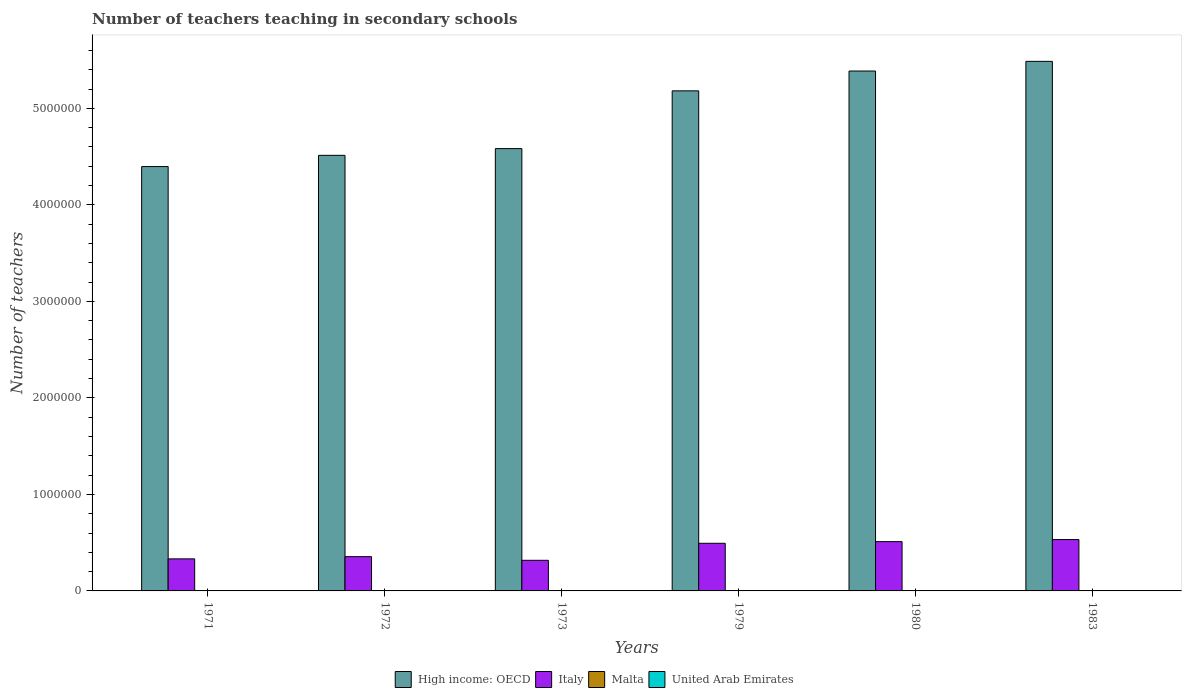Are the number of bars on each tick of the X-axis equal?
Your answer should be compact. Yes. How many bars are there on the 5th tick from the left?
Give a very brief answer. 4. In how many cases, is the number of bars for a given year not equal to the number of legend labels?
Provide a short and direct response. 0. What is the number of teachers teaching in secondary schools in Italy in 1980?
Make the answer very short. 5.11e+05. Across all years, what is the maximum number of teachers teaching in secondary schools in Malta?
Your response must be concise. 2381. Across all years, what is the minimum number of teachers teaching in secondary schools in Malta?
Keep it short and to the point. 1662. In which year was the number of teachers teaching in secondary schools in Italy maximum?
Ensure brevity in your answer.  1983. In which year was the number of teachers teaching in secondary schools in United Arab Emirates minimum?
Your response must be concise. 1971. What is the total number of teachers teaching in secondary schools in Malta in the graph?
Keep it short and to the point. 1.30e+04. What is the difference between the number of teachers teaching in secondary schools in High income: OECD in 1972 and that in 1983?
Give a very brief answer. -9.74e+05. What is the difference between the number of teachers teaching in secondary schools in United Arab Emirates in 1983 and the number of teachers teaching in secondary schools in Italy in 1980?
Keep it short and to the point. -5.07e+05. What is the average number of teachers teaching in secondary schools in Malta per year?
Provide a short and direct response. 2165. In the year 1972, what is the difference between the number of teachers teaching in secondary schools in High income: OECD and number of teachers teaching in secondary schools in Italy?
Offer a terse response. 4.16e+06. In how many years, is the number of teachers teaching in secondary schools in Malta greater than 1400000?
Your answer should be compact. 0. What is the ratio of the number of teachers teaching in secondary schools in Malta in 1980 to that in 1983?
Your answer should be compact. 0.99. Is the number of teachers teaching in secondary schools in High income: OECD in 1971 less than that in 1973?
Provide a succinct answer. Yes. What is the difference between the highest and the second highest number of teachers teaching in secondary schools in High income: OECD?
Your answer should be compact. 1.00e+05. What is the difference between the highest and the lowest number of teachers teaching in secondary schools in Italy?
Ensure brevity in your answer.  2.15e+05. In how many years, is the number of teachers teaching in secondary schools in Italy greater than the average number of teachers teaching in secondary schools in Italy taken over all years?
Offer a very short reply. 3. Is it the case that in every year, the sum of the number of teachers teaching in secondary schools in High income: OECD and number of teachers teaching in secondary schools in United Arab Emirates is greater than the sum of number of teachers teaching in secondary schools in Malta and number of teachers teaching in secondary schools in Italy?
Provide a short and direct response. Yes. What does the 2nd bar from the left in 1973 represents?
Your answer should be very brief. Italy. What does the 3rd bar from the right in 1973 represents?
Make the answer very short. Italy. Is it the case that in every year, the sum of the number of teachers teaching in secondary schools in United Arab Emirates and number of teachers teaching in secondary schools in Malta is greater than the number of teachers teaching in secondary schools in High income: OECD?
Make the answer very short. No. How many bars are there?
Ensure brevity in your answer.  24. How many years are there in the graph?
Your response must be concise. 6. What is the difference between two consecutive major ticks on the Y-axis?
Make the answer very short. 1.00e+06. Are the values on the major ticks of Y-axis written in scientific E-notation?
Give a very brief answer. No. What is the title of the graph?
Keep it short and to the point. Number of teachers teaching in secondary schools. Does "South Africa" appear as one of the legend labels in the graph?
Ensure brevity in your answer.  No. What is the label or title of the X-axis?
Make the answer very short. Years. What is the label or title of the Y-axis?
Your answer should be very brief. Number of teachers. What is the Number of teachers in High income: OECD in 1971?
Your response must be concise. 4.40e+06. What is the Number of teachers in Italy in 1971?
Make the answer very short. 3.32e+05. What is the Number of teachers in Malta in 1971?
Your response must be concise. 1662. What is the Number of teachers in United Arab Emirates in 1971?
Make the answer very short. 363. What is the Number of teachers in High income: OECD in 1972?
Give a very brief answer. 4.51e+06. What is the Number of teachers of Italy in 1972?
Your answer should be very brief. 3.55e+05. What is the Number of teachers in Malta in 1972?
Give a very brief answer. 2381. What is the Number of teachers in United Arab Emirates in 1972?
Keep it short and to the point. 471. What is the Number of teachers in High income: OECD in 1973?
Ensure brevity in your answer.  4.58e+06. What is the Number of teachers in Italy in 1973?
Provide a succinct answer. 3.17e+05. What is the Number of teachers in Malta in 1973?
Ensure brevity in your answer.  2174. What is the Number of teachers of United Arab Emirates in 1973?
Make the answer very short. 713. What is the Number of teachers in High income: OECD in 1979?
Your answer should be very brief. 5.18e+06. What is the Number of teachers of Italy in 1979?
Provide a succinct answer. 4.94e+05. What is the Number of teachers of Malta in 1979?
Give a very brief answer. 2291. What is the Number of teachers in United Arab Emirates in 1979?
Make the answer very short. 2161. What is the Number of teachers of High income: OECD in 1980?
Keep it short and to the point. 5.39e+06. What is the Number of teachers in Italy in 1980?
Make the answer very short. 5.11e+05. What is the Number of teachers of Malta in 1980?
Offer a very short reply. 2229. What is the Number of teachers of United Arab Emirates in 1980?
Provide a short and direct response. 2582. What is the Number of teachers of High income: OECD in 1983?
Your response must be concise. 5.49e+06. What is the Number of teachers of Italy in 1983?
Keep it short and to the point. 5.32e+05. What is the Number of teachers of Malta in 1983?
Keep it short and to the point. 2253. What is the Number of teachers of United Arab Emirates in 1983?
Ensure brevity in your answer.  3588. Across all years, what is the maximum Number of teachers in High income: OECD?
Provide a short and direct response. 5.49e+06. Across all years, what is the maximum Number of teachers in Italy?
Keep it short and to the point. 5.32e+05. Across all years, what is the maximum Number of teachers in Malta?
Give a very brief answer. 2381. Across all years, what is the maximum Number of teachers in United Arab Emirates?
Provide a succinct answer. 3588. Across all years, what is the minimum Number of teachers of High income: OECD?
Provide a short and direct response. 4.40e+06. Across all years, what is the minimum Number of teachers of Italy?
Provide a succinct answer. 3.17e+05. Across all years, what is the minimum Number of teachers of Malta?
Offer a terse response. 1662. Across all years, what is the minimum Number of teachers in United Arab Emirates?
Provide a succinct answer. 363. What is the total Number of teachers of High income: OECD in the graph?
Ensure brevity in your answer.  2.95e+07. What is the total Number of teachers in Italy in the graph?
Your response must be concise. 2.54e+06. What is the total Number of teachers in Malta in the graph?
Your answer should be compact. 1.30e+04. What is the total Number of teachers of United Arab Emirates in the graph?
Provide a short and direct response. 9878. What is the difference between the Number of teachers in High income: OECD in 1971 and that in 1972?
Your response must be concise. -1.16e+05. What is the difference between the Number of teachers in Italy in 1971 and that in 1972?
Your response must be concise. -2.29e+04. What is the difference between the Number of teachers in Malta in 1971 and that in 1972?
Offer a very short reply. -719. What is the difference between the Number of teachers in United Arab Emirates in 1971 and that in 1972?
Make the answer very short. -108. What is the difference between the Number of teachers in High income: OECD in 1971 and that in 1973?
Provide a short and direct response. -1.86e+05. What is the difference between the Number of teachers of Italy in 1971 and that in 1973?
Offer a terse response. 1.49e+04. What is the difference between the Number of teachers of Malta in 1971 and that in 1973?
Give a very brief answer. -512. What is the difference between the Number of teachers in United Arab Emirates in 1971 and that in 1973?
Offer a very short reply. -350. What is the difference between the Number of teachers in High income: OECD in 1971 and that in 1979?
Your answer should be compact. -7.84e+05. What is the difference between the Number of teachers in Italy in 1971 and that in 1979?
Make the answer very short. -1.61e+05. What is the difference between the Number of teachers of Malta in 1971 and that in 1979?
Your answer should be compact. -629. What is the difference between the Number of teachers in United Arab Emirates in 1971 and that in 1979?
Offer a terse response. -1798. What is the difference between the Number of teachers of High income: OECD in 1971 and that in 1980?
Your answer should be compact. -9.90e+05. What is the difference between the Number of teachers of Italy in 1971 and that in 1980?
Your response must be concise. -1.79e+05. What is the difference between the Number of teachers in Malta in 1971 and that in 1980?
Your answer should be very brief. -567. What is the difference between the Number of teachers in United Arab Emirates in 1971 and that in 1980?
Your answer should be compact. -2219. What is the difference between the Number of teachers in High income: OECD in 1971 and that in 1983?
Keep it short and to the point. -1.09e+06. What is the difference between the Number of teachers of Italy in 1971 and that in 1983?
Make the answer very short. -2.00e+05. What is the difference between the Number of teachers in Malta in 1971 and that in 1983?
Your answer should be compact. -591. What is the difference between the Number of teachers of United Arab Emirates in 1971 and that in 1983?
Your answer should be compact. -3225. What is the difference between the Number of teachers in High income: OECD in 1972 and that in 1973?
Your answer should be compact. -6.96e+04. What is the difference between the Number of teachers of Italy in 1972 and that in 1973?
Keep it short and to the point. 3.78e+04. What is the difference between the Number of teachers in Malta in 1972 and that in 1973?
Keep it short and to the point. 207. What is the difference between the Number of teachers in United Arab Emirates in 1972 and that in 1973?
Ensure brevity in your answer.  -242. What is the difference between the Number of teachers in High income: OECD in 1972 and that in 1979?
Ensure brevity in your answer.  -6.68e+05. What is the difference between the Number of teachers of Italy in 1972 and that in 1979?
Ensure brevity in your answer.  -1.39e+05. What is the difference between the Number of teachers in United Arab Emirates in 1972 and that in 1979?
Your response must be concise. -1690. What is the difference between the Number of teachers of High income: OECD in 1972 and that in 1980?
Make the answer very short. -8.74e+05. What is the difference between the Number of teachers in Italy in 1972 and that in 1980?
Ensure brevity in your answer.  -1.56e+05. What is the difference between the Number of teachers of Malta in 1972 and that in 1980?
Provide a succinct answer. 152. What is the difference between the Number of teachers of United Arab Emirates in 1972 and that in 1980?
Give a very brief answer. -2111. What is the difference between the Number of teachers of High income: OECD in 1972 and that in 1983?
Your answer should be very brief. -9.74e+05. What is the difference between the Number of teachers of Italy in 1972 and that in 1983?
Provide a succinct answer. -1.77e+05. What is the difference between the Number of teachers in Malta in 1972 and that in 1983?
Offer a very short reply. 128. What is the difference between the Number of teachers of United Arab Emirates in 1972 and that in 1983?
Your answer should be very brief. -3117. What is the difference between the Number of teachers of High income: OECD in 1973 and that in 1979?
Give a very brief answer. -5.98e+05. What is the difference between the Number of teachers in Italy in 1973 and that in 1979?
Your answer should be compact. -1.76e+05. What is the difference between the Number of teachers in Malta in 1973 and that in 1979?
Keep it short and to the point. -117. What is the difference between the Number of teachers in United Arab Emirates in 1973 and that in 1979?
Provide a short and direct response. -1448. What is the difference between the Number of teachers in High income: OECD in 1973 and that in 1980?
Ensure brevity in your answer.  -8.04e+05. What is the difference between the Number of teachers of Italy in 1973 and that in 1980?
Your answer should be very brief. -1.94e+05. What is the difference between the Number of teachers in Malta in 1973 and that in 1980?
Make the answer very short. -55. What is the difference between the Number of teachers of United Arab Emirates in 1973 and that in 1980?
Provide a succinct answer. -1869. What is the difference between the Number of teachers of High income: OECD in 1973 and that in 1983?
Your response must be concise. -9.04e+05. What is the difference between the Number of teachers in Italy in 1973 and that in 1983?
Your answer should be compact. -2.15e+05. What is the difference between the Number of teachers in Malta in 1973 and that in 1983?
Keep it short and to the point. -79. What is the difference between the Number of teachers in United Arab Emirates in 1973 and that in 1983?
Your response must be concise. -2875. What is the difference between the Number of teachers of High income: OECD in 1979 and that in 1980?
Keep it short and to the point. -2.05e+05. What is the difference between the Number of teachers of Italy in 1979 and that in 1980?
Give a very brief answer. -1.72e+04. What is the difference between the Number of teachers in Malta in 1979 and that in 1980?
Provide a short and direct response. 62. What is the difference between the Number of teachers of United Arab Emirates in 1979 and that in 1980?
Your response must be concise. -421. What is the difference between the Number of teachers in High income: OECD in 1979 and that in 1983?
Your answer should be very brief. -3.06e+05. What is the difference between the Number of teachers in Italy in 1979 and that in 1983?
Provide a short and direct response. -3.88e+04. What is the difference between the Number of teachers in United Arab Emirates in 1979 and that in 1983?
Give a very brief answer. -1427. What is the difference between the Number of teachers of High income: OECD in 1980 and that in 1983?
Give a very brief answer. -1.00e+05. What is the difference between the Number of teachers of Italy in 1980 and that in 1983?
Ensure brevity in your answer.  -2.15e+04. What is the difference between the Number of teachers in Malta in 1980 and that in 1983?
Ensure brevity in your answer.  -24. What is the difference between the Number of teachers in United Arab Emirates in 1980 and that in 1983?
Give a very brief answer. -1006. What is the difference between the Number of teachers in High income: OECD in 1971 and the Number of teachers in Italy in 1972?
Keep it short and to the point. 4.04e+06. What is the difference between the Number of teachers of High income: OECD in 1971 and the Number of teachers of Malta in 1972?
Make the answer very short. 4.39e+06. What is the difference between the Number of teachers in High income: OECD in 1971 and the Number of teachers in United Arab Emirates in 1972?
Provide a succinct answer. 4.40e+06. What is the difference between the Number of teachers in Italy in 1971 and the Number of teachers in Malta in 1972?
Your answer should be compact. 3.30e+05. What is the difference between the Number of teachers in Italy in 1971 and the Number of teachers in United Arab Emirates in 1972?
Provide a succinct answer. 3.32e+05. What is the difference between the Number of teachers in Malta in 1971 and the Number of teachers in United Arab Emirates in 1972?
Keep it short and to the point. 1191. What is the difference between the Number of teachers in High income: OECD in 1971 and the Number of teachers in Italy in 1973?
Provide a short and direct response. 4.08e+06. What is the difference between the Number of teachers in High income: OECD in 1971 and the Number of teachers in Malta in 1973?
Provide a succinct answer. 4.39e+06. What is the difference between the Number of teachers in High income: OECD in 1971 and the Number of teachers in United Arab Emirates in 1973?
Your response must be concise. 4.40e+06. What is the difference between the Number of teachers in Italy in 1971 and the Number of teachers in Malta in 1973?
Provide a succinct answer. 3.30e+05. What is the difference between the Number of teachers of Italy in 1971 and the Number of teachers of United Arab Emirates in 1973?
Offer a very short reply. 3.31e+05. What is the difference between the Number of teachers in Malta in 1971 and the Number of teachers in United Arab Emirates in 1973?
Provide a succinct answer. 949. What is the difference between the Number of teachers of High income: OECD in 1971 and the Number of teachers of Italy in 1979?
Keep it short and to the point. 3.90e+06. What is the difference between the Number of teachers in High income: OECD in 1971 and the Number of teachers in Malta in 1979?
Provide a succinct answer. 4.39e+06. What is the difference between the Number of teachers of High income: OECD in 1971 and the Number of teachers of United Arab Emirates in 1979?
Your answer should be very brief. 4.39e+06. What is the difference between the Number of teachers in Italy in 1971 and the Number of teachers in Malta in 1979?
Give a very brief answer. 3.30e+05. What is the difference between the Number of teachers in Italy in 1971 and the Number of teachers in United Arab Emirates in 1979?
Give a very brief answer. 3.30e+05. What is the difference between the Number of teachers in Malta in 1971 and the Number of teachers in United Arab Emirates in 1979?
Give a very brief answer. -499. What is the difference between the Number of teachers of High income: OECD in 1971 and the Number of teachers of Italy in 1980?
Provide a short and direct response. 3.89e+06. What is the difference between the Number of teachers of High income: OECD in 1971 and the Number of teachers of Malta in 1980?
Offer a very short reply. 4.39e+06. What is the difference between the Number of teachers of High income: OECD in 1971 and the Number of teachers of United Arab Emirates in 1980?
Offer a very short reply. 4.39e+06. What is the difference between the Number of teachers of Italy in 1971 and the Number of teachers of Malta in 1980?
Offer a very short reply. 3.30e+05. What is the difference between the Number of teachers in Italy in 1971 and the Number of teachers in United Arab Emirates in 1980?
Offer a very short reply. 3.30e+05. What is the difference between the Number of teachers of Malta in 1971 and the Number of teachers of United Arab Emirates in 1980?
Offer a terse response. -920. What is the difference between the Number of teachers of High income: OECD in 1971 and the Number of teachers of Italy in 1983?
Offer a very short reply. 3.86e+06. What is the difference between the Number of teachers in High income: OECD in 1971 and the Number of teachers in Malta in 1983?
Your response must be concise. 4.39e+06. What is the difference between the Number of teachers in High income: OECD in 1971 and the Number of teachers in United Arab Emirates in 1983?
Provide a short and direct response. 4.39e+06. What is the difference between the Number of teachers in Italy in 1971 and the Number of teachers in Malta in 1983?
Make the answer very short. 3.30e+05. What is the difference between the Number of teachers of Italy in 1971 and the Number of teachers of United Arab Emirates in 1983?
Offer a very short reply. 3.29e+05. What is the difference between the Number of teachers in Malta in 1971 and the Number of teachers in United Arab Emirates in 1983?
Provide a short and direct response. -1926. What is the difference between the Number of teachers in High income: OECD in 1972 and the Number of teachers in Italy in 1973?
Provide a short and direct response. 4.20e+06. What is the difference between the Number of teachers in High income: OECD in 1972 and the Number of teachers in Malta in 1973?
Offer a terse response. 4.51e+06. What is the difference between the Number of teachers in High income: OECD in 1972 and the Number of teachers in United Arab Emirates in 1973?
Offer a terse response. 4.51e+06. What is the difference between the Number of teachers in Italy in 1972 and the Number of teachers in Malta in 1973?
Provide a short and direct response. 3.53e+05. What is the difference between the Number of teachers in Italy in 1972 and the Number of teachers in United Arab Emirates in 1973?
Make the answer very short. 3.54e+05. What is the difference between the Number of teachers of Malta in 1972 and the Number of teachers of United Arab Emirates in 1973?
Offer a very short reply. 1668. What is the difference between the Number of teachers in High income: OECD in 1972 and the Number of teachers in Italy in 1979?
Your response must be concise. 4.02e+06. What is the difference between the Number of teachers of High income: OECD in 1972 and the Number of teachers of Malta in 1979?
Provide a succinct answer. 4.51e+06. What is the difference between the Number of teachers of High income: OECD in 1972 and the Number of teachers of United Arab Emirates in 1979?
Offer a very short reply. 4.51e+06. What is the difference between the Number of teachers of Italy in 1972 and the Number of teachers of Malta in 1979?
Make the answer very short. 3.53e+05. What is the difference between the Number of teachers of Italy in 1972 and the Number of teachers of United Arab Emirates in 1979?
Make the answer very short. 3.53e+05. What is the difference between the Number of teachers in Malta in 1972 and the Number of teachers in United Arab Emirates in 1979?
Keep it short and to the point. 220. What is the difference between the Number of teachers of High income: OECD in 1972 and the Number of teachers of Italy in 1980?
Give a very brief answer. 4.00e+06. What is the difference between the Number of teachers of High income: OECD in 1972 and the Number of teachers of Malta in 1980?
Make the answer very short. 4.51e+06. What is the difference between the Number of teachers in High income: OECD in 1972 and the Number of teachers in United Arab Emirates in 1980?
Provide a short and direct response. 4.51e+06. What is the difference between the Number of teachers of Italy in 1972 and the Number of teachers of Malta in 1980?
Your answer should be very brief. 3.53e+05. What is the difference between the Number of teachers in Italy in 1972 and the Number of teachers in United Arab Emirates in 1980?
Give a very brief answer. 3.52e+05. What is the difference between the Number of teachers in Malta in 1972 and the Number of teachers in United Arab Emirates in 1980?
Offer a terse response. -201. What is the difference between the Number of teachers of High income: OECD in 1972 and the Number of teachers of Italy in 1983?
Provide a short and direct response. 3.98e+06. What is the difference between the Number of teachers of High income: OECD in 1972 and the Number of teachers of Malta in 1983?
Keep it short and to the point. 4.51e+06. What is the difference between the Number of teachers of High income: OECD in 1972 and the Number of teachers of United Arab Emirates in 1983?
Keep it short and to the point. 4.51e+06. What is the difference between the Number of teachers in Italy in 1972 and the Number of teachers in Malta in 1983?
Offer a terse response. 3.53e+05. What is the difference between the Number of teachers in Italy in 1972 and the Number of teachers in United Arab Emirates in 1983?
Give a very brief answer. 3.51e+05. What is the difference between the Number of teachers of Malta in 1972 and the Number of teachers of United Arab Emirates in 1983?
Make the answer very short. -1207. What is the difference between the Number of teachers of High income: OECD in 1973 and the Number of teachers of Italy in 1979?
Offer a terse response. 4.09e+06. What is the difference between the Number of teachers in High income: OECD in 1973 and the Number of teachers in Malta in 1979?
Ensure brevity in your answer.  4.58e+06. What is the difference between the Number of teachers of High income: OECD in 1973 and the Number of teachers of United Arab Emirates in 1979?
Your answer should be very brief. 4.58e+06. What is the difference between the Number of teachers of Italy in 1973 and the Number of teachers of Malta in 1979?
Offer a very short reply. 3.15e+05. What is the difference between the Number of teachers of Italy in 1973 and the Number of teachers of United Arab Emirates in 1979?
Keep it short and to the point. 3.15e+05. What is the difference between the Number of teachers of High income: OECD in 1973 and the Number of teachers of Italy in 1980?
Provide a succinct answer. 4.07e+06. What is the difference between the Number of teachers in High income: OECD in 1973 and the Number of teachers in Malta in 1980?
Keep it short and to the point. 4.58e+06. What is the difference between the Number of teachers in High income: OECD in 1973 and the Number of teachers in United Arab Emirates in 1980?
Provide a short and direct response. 4.58e+06. What is the difference between the Number of teachers of Italy in 1973 and the Number of teachers of Malta in 1980?
Make the answer very short. 3.15e+05. What is the difference between the Number of teachers in Italy in 1973 and the Number of teachers in United Arab Emirates in 1980?
Provide a short and direct response. 3.15e+05. What is the difference between the Number of teachers in Malta in 1973 and the Number of teachers in United Arab Emirates in 1980?
Offer a terse response. -408. What is the difference between the Number of teachers in High income: OECD in 1973 and the Number of teachers in Italy in 1983?
Provide a succinct answer. 4.05e+06. What is the difference between the Number of teachers in High income: OECD in 1973 and the Number of teachers in Malta in 1983?
Offer a very short reply. 4.58e+06. What is the difference between the Number of teachers of High income: OECD in 1973 and the Number of teachers of United Arab Emirates in 1983?
Keep it short and to the point. 4.58e+06. What is the difference between the Number of teachers of Italy in 1973 and the Number of teachers of Malta in 1983?
Keep it short and to the point. 3.15e+05. What is the difference between the Number of teachers of Italy in 1973 and the Number of teachers of United Arab Emirates in 1983?
Offer a very short reply. 3.14e+05. What is the difference between the Number of teachers of Malta in 1973 and the Number of teachers of United Arab Emirates in 1983?
Keep it short and to the point. -1414. What is the difference between the Number of teachers in High income: OECD in 1979 and the Number of teachers in Italy in 1980?
Your answer should be compact. 4.67e+06. What is the difference between the Number of teachers in High income: OECD in 1979 and the Number of teachers in Malta in 1980?
Make the answer very short. 5.18e+06. What is the difference between the Number of teachers in High income: OECD in 1979 and the Number of teachers in United Arab Emirates in 1980?
Give a very brief answer. 5.18e+06. What is the difference between the Number of teachers of Italy in 1979 and the Number of teachers of Malta in 1980?
Your answer should be compact. 4.91e+05. What is the difference between the Number of teachers in Italy in 1979 and the Number of teachers in United Arab Emirates in 1980?
Keep it short and to the point. 4.91e+05. What is the difference between the Number of teachers in Malta in 1979 and the Number of teachers in United Arab Emirates in 1980?
Keep it short and to the point. -291. What is the difference between the Number of teachers of High income: OECD in 1979 and the Number of teachers of Italy in 1983?
Keep it short and to the point. 4.65e+06. What is the difference between the Number of teachers in High income: OECD in 1979 and the Number of teachers in Malta in 1983?
Give a very brief answer. 5.18e+06. What is the difference between the Number of teachers in High income: OECD in 1979 and the Number of teachers in United Arab Emirates in 1983?
Give a very brief answer. 5.18e+06. What is the difference between the Number of teachers in Italy in 1979 and the Number of teachers in Malta in 1983?
Keep it short and to the point. 4.91e+05. What is the difference between the Number of teachers in Italy in 1979 and the Number of teachers in United Arab Emirates in 1983?
Your answer should be very brief. 4.90e+05. What is the difference between the Number of teachers of Malta in 1979 and the Number of teachers of United Arab Emirates in 1983?
Keep it short and to the point. -1297. What is the difference between the Number of teachers of High income: OECD in 1980 and the Number of teachers of Italy in 1983?
Your response must be concise. 4.85e+06. What is the difference between the Number of teachers in High income: OECD in 1980 and the Number of teachers in Malta in 1983?
Your response must be concise. 5.38e+06. What is the difference between the Number of teachers of High income: OECD in 1980 and the Number of teachers of United Arab Emirates in 1983?
Provide a succinct answer. 5.38e+06. What is the difference between the Number of teachers of Italy in 1980 and the Number of teachers of Malta in 1983?
Make the answer very short. 5.09e+05. What is the difference between the Number of teachers in Italy in 1980 and the Number of teachers in United Arab Emirates in 1983?
Your response must be concise. 5.07e+05. What is the difference between the Number of teachers in Malta in 1980 and the Number of teachers in United Arab Emirates in 1983?
Offer a terse response. -1359. What is the average Number of teachers in High income: OECD per year?
Keep it short and to the point. 4.92e+06. What is the average Number of teachers of Italy per year?
Ensure brevity in your answer.  4.23e+05. What is the average Number of teachers of Malta per year?
Provide a succinct answer. 2165. What is the average Number of teachers of United Arab Emirates per year?
Your answer should be very brief. 1646.33. In the year 1971, what is the difference between the Number of teachers in High income: OECD and Number of teachers in Italy?
Make the answer very short. 4.06e+06. In the year 1971, what is the difference between the Number of teachers of High income: OECD and Number of teachers of Malta?
Provide a short and direct response. 4.40e+06. In the year 1971, what is the difference between the Number of teachers in High income: OECD and Number of teachers in United Arab Emirates?
Your answer should be compact. 4.40e+06. In the year 1971, what is the difference between the Number of teachers in Italy and Number of teachers in Malta?
Provide a succinct answer. 3.30e+05. In the year 1971, what is the difference between the Number of teachers in Italy and Number of teachers in United Arab Emirates?
Make the answer very short. 3.32e+05. In the year 1971, what is the difference between the Number of teachers in Malta and Number of teachers in United Arab Emirates?
Your answer should be compact. 1299. In the year 1972, what is the difference between the Number of teachers of High income: OECD and Number of teachers of Italy?
Offer a terse response. 4.16e+06. In the year 1972, what is the difference between the Number of teachers in High income: OECD and Number of teachers in Malta?
Your response must be concise. 4.51e+06. In the year 1972, what is the difference between the Number of teachers of High income: OECD and Number of teachers of United Arab Emirates?
Make the answer very short. 4.51e+06. In the year 1972, what is the difference between the Number of teachers in Italy and Number of teachers in Malta?
Offer a terse response. 3.53e+05. In the year 1972, what is the difference between the Number of teachers of Italy and Number of teachers of United Arab Emirates?
Your answer should be very brief. 3.55e+05. In the year 1972, what is the difference between the Number of teachers in Malta and Number of teachers in United Arab Emirates?
Make the answer very short. 1910. In the year 1973, what is the difference between the Number of teachers of High income: OECD and Number of teachers of Italy?
Offer a very short reply. 4.27e+06. In the year 1973, what is the difference between the Number of teachers in High income: OECD and Number of teachers in Malta?
Offer a terse response. 4.58e+06. In the year 1973, what is the difference between the Number of teachers of High income: OECD and Number of teachers of United Arab Emirates?
Provide a short and direct response. 4.58e+06. In the year 1973, what is the difference between the Number of teachers of Italy and Number of teachers of Malta?
Your answer should be compact. 3.15e+05. In the year 1973, what is the difference between the Number of teachers of Italy and Number of teachers of United Arab Emirates?
Your answer should be very brief. 3.16e+05. In the year 1973, what is the difference between the Number of teachers of Malta and Number of teachers of United Arab Emirates?
Give a very brief answer. 1461. In the year 1979, what is the difference between the Number of teachers in High income: OECD and Number of teachers in Italy?
Give a very brief answer. 4.69e+06. In the year 1979, what is the difference between the Number of teachers of High income: OECD and Number of teachers of Malta?
Offer a very short reply. 5.18e+06. In the year 1979, what is the difference between the Number of teachers of High income: OECD and Number of teachers of United Arab Emirates?
Offer a terse response. 5.18e+06. In the year 1979, what is the difference between the Number of teachers of Italy and Number of teachers of Malta?
Make the answer very short. 4.91e+05. In the year 1979, what is the difference between the Number of teachers in Italy and Number of teachers in United Arab Emirates?
Keep it short and to the point. 4.91e+05. In the year 1979, what is the difference between the Number of teachers in Malta and Number of teachers in United Arab Emirates?
Provide a succinct answer. 130. In the year 1980, what is the difference between the Number of teachers in High income: OECD and Number of teachers in Italy?
Make the answer very short. 4.88e+06. In the year 1980, what is the difference between the Number of teachers in High income: OECD and Number of teachers in Malta?
Offer a terse response. 5.38e+06. In the year 1980, what is the difference between the Number of teachers of High income: OECD and Number of teachers of United Arab Emirates?
Provide a short and direct response. 5.38e+06. In the year 1980, what is the difference between the Number of teachers in Italy and Number of teachers in Malta?
Offer a very short reply. 5.09e+05. In the year 1980, what is the difference between the Number of teachers in Italy and Number of teachers in United Arab Emirates?
Your answer should be compact. 5.08e+05. In the year 1980, what is the difference between the Number of teachers of Malta and Number of teachers of United Arab Emirates?
Your response must be concise. -353. In the year 1983, what is the difference between the Number of teachers of High income: OECD and Number of teachers of Italy?
Offer a very short reply. 4.95e+06. In the year 1983, what is the difference between the Number of teachers in High income: OECD and Number of teachers in Malta?
Offer a very short reply. 5.48e+06. In the year 1983, what is the difference between the Number of teachers of High income: OECD and Number of teachers of United Arab Emirates?
Keep it short and to the point. 5.48e+06. In the year 1983, what is the difference between the Number of teachers in Italy and Number of teachers in Malta?
Make the answer very short. 5.30e+05. In the year 1983, what is the difference between the Number of teachers of Italy and Number of teachers of United Arab Emirates?
Keep it short and to the point. 5.29e+05. In the year 1983, what is the difference between the Number of teachers in Malta and Number of teachers in United Arab Emirates?
Your answer should be compact. -1335. What is the ratio of the Number of teachers of High income: OECD in 1971 to that in 1972?
Offer a very short reply. 0.97. What is the ratio of the Number of teachers in Italy in 1971 to that in 1972?
Offer a terse response. 0.94. What is the ratio of the Number of teachers of Malta in 1971 to that in 1972?
Offer a very short reply. 0.7. What is the ratio of the Number of teachers in United Arab Emirates in 1971 to that in 1972?
Provide a short and direct response. 0.77. What is the ratio of the Number of teachers in High income: OECD in 1971 to that in 1973?
Offer a very short reply. 0.96. What is the ratio of the Number of teachers in Italy in 1971 to that in 1973?
Offer a terse response. 1.05. What is the ratio of the Number of teachers of Malta in 1971 to that in 1973?
Give a very brief answer. 0.76. What is the ratio of the Number of teachers in United Arab Emirates in 1971 to that in 1973?
Your answer should be very brief. 0.51. What is the ratio of the Number of teachers in High income: OECD in 1971 to that in 1979?
Provide a short and direct response. 0.85. What is the ratio of the Number of teachers in Italy in 1971 to that in 1979?
Your response must be concise. 0.67. What is the ratio of the Number of teachers of Malta in 1971 to that in 1979?
Provide a succinct answer. 0.73. What is the ratio of the Number of teachers of United Arab Emirates in 1971 to that in 1979?
Your answer should be compact. 0.17. What is the ratio of the Number of teachers of High income: OECD in 1971 to that in 1980?
Make the answer very short. 0.82. What is the ratio of the Number of teachers in Italy in 1971 to that in 1980?
Make the answer very short. 0.65. What is the ratio of the Number of teachers of Malta in 1971 to that in 1980?
Provide a succinct answer. 0.75. What is the ratio of the Number of teachers in United Arab Emirates in 1971 to that in 1980?
Keep it short and to the point. 0.14. What is the ratio of the Number of teachers in High income: OECD in 1971 to that in 1983?
Your answer should be very brief. 0.8. What is the ratio of the Number of teachers in Italy in 1971 to that in 1983?
Keep it short and to the point. 0.62. What is the ratio of the Number of teachers of Malta in 1971 to that in 1983?
Offer a very short reply. 0.74. What is the ratio of the Number of teachers of United Arab Emirates in 1971 to that in 1983?
Your answer should be compact. 0.1. What is the ratio of the Number of teachers of Italy in 1972 to that in 1973?
Your answer should be very brief. 1.12. What is the ratio of the Number of teachers of Malta in 1972 to that in 1973?
Your answer should be compact. 1.1. What is the ratio of the Number of teachers in United Arab Emirates in 1972 to that in 1973?
Give a very brief answer. 0.66. What is the ratio of the Number of teachers of High income: OECD in 1972 to that in 1979?
Your answer should be very brief. 0.87. What is the ratio of the Number of teachers of Italy in 1972 to that in 1979?
Your answer should be compact. 0.72. What is the ratio of the Number of teachers of Malta in 1972 to that in 1979?
Give a very brief answer. 1.04. What is the ratio of the Number of teachers of United Arab Emirates in 1972 to that in 1979?
Provide a short and direct response. 0.22. What is the ratio of the Number of teachers of High income: OECD in 1972 to that in 1980?
Your answer should be very brief. 0.84. What is the ratio of the Number of teachers of Italy in 1972 to that in 1980?
Your answer should be compact. 0.69. What is the ratio of the Number of teachers of Malta in 1972 to that in 1980?
Give a very brief answer. 1.07. What is the ratio of the Number of teachers in United Arab Emirates in 1972 to that in 1980?
Your answer should be very brief. 0.18. What is the ratio of the Number of teachers of High income: OECD in 1972 to that in 1983?
Your response must be concise. 0.82. What is the ratio of the Number of teachers of Italy in 1972 to that in 1983?
Make the answer very short. 0.67. What is the ratio of the Number of teachers of Malta in 1972 to that in 1983?
Your answer should be very brief. 1.06. What is the ratio of the Number of teachers of United Arab Emirates in 1972 to that in 1983?
Provide a succinct answer. 0.13. What is the ratio of the Number of teachers of High income: OECD in 1973 to that in 1979?
Provide a short and direct response. 0.88. What is the ratio of the Number of teachers of Italy in 1973 to that in 1979?
Ensure brevity in your answer.  0.64. What is the ratio of the Number of teachers of Malta in 1973 to that in 1979?
Provide a succinct answer. 0.95. What is the ratio of the Number of teachers of United Arab Emirates in 1973 to that in 1979?
Ensure brevity in your answer.  0.33. What is the ratio of the Number of teachers of High income: OECD in 1973 to that in 1980?
Your response must be concise. 0.85. What is the ratio of the Number of teachers of Italy in 1973 to that in 1980?
Provide a succinct answer. 0.62. What is the ratio of the Number of teachers of Malta in 1973 to that in 1980?
Provide a short and direct response. 0.98. What is the ratio of the Number of teachers in United Arab Emirates in 1973 to that in 1980?
Make the answer very short. 0.28. What is the ratio of the Number of teachers of High income: OECD in 1973 to that in 1983?
Your response must be concise. 0.84. What is the ratio of the Number of teachers of Italy in 1973 to that in 1983?
Provide a succinct answer. 0.6. What is the ratio of the Number of teachers of Malta in 1973 to that in 1983?
Make the answer very short. 0.96. What is the ratio of the Number of teachers in United Arab Emirates in 1973 to that in 1983?
Your answer should be very brief. 0.2. What is the ratio of the Number of teachers of High income: OECD in 1979 to that in 1980?
Your answer should be compact. 0.96. What is the ratio of the Number of teachers in Italy in 1979 to that in 1980?
Ensure brevity in your answer.  0.97. What is the ratio of the Number of teachers in Malta in 1979 to that in 1980?
Offer a terse response. 1.03. What is the ratio of the Number of teachers in United Arab Emirates in 1979 to that in 1980?
Keep it short and to the point. 0.84. What is the ratio of the Number of teachers of High income: OECD in 1979 to that in 1983?
Your response must be concise. 0.94. What is the ratio of the Number of teachers of Italy in 1979 to that in 1983?
Your answer should be compact. 0.93. What is the ratio of the Number of teachers of Malta in 1979 to that in 1983?
Your answer should be very brief. 1.02. What is the ratio of the Number of teachers in United Arab Emirates in 1979 to that in 1983?
Make the answer very short. 0.6. What is the ratio of the Number of teachers in High income: OECD in 1980 to that in 1983?
Your answer should be very brief. 0.98. What is the ratio of the Number of teachers of Italy in 1980 to that in 1983?
Your answer should be compact. 0.96. What is the ratio of the Number of teachers of Malta in 1980 to that in 1983?
Ensure brevity in your answer.  0.99. What is the ratio of the Number of teachers in United Arab Emirates in 1980 to that in 1983?
Keep it short and to the point. 0.72. What is the difference between the highest and the second highest Number of teachers of High income: OECD?
Ensure brevity in your answer.  1.00e+05. What is the difference between the highest and the second highest Number of teachers in Italy?
Make the answer very short. 2.15e+04. What is the difference between the highest and the second highest Number of teachers of United Arab Emirates?
Your answer should be very brief. 1006. What is the difference between the highest and the lowest Number of teachers of High income: OECD?
Your answer should be compact. 1.09e+06. What is the difference between the highest and the lowest Number of teachers in Italy?
Provide a short and direct response. 2.15e+05. What is the difference between the highest and the lowest Number of teachers in Malta?
Provide a succinct answer. 719. What is the difference between the highest and the lowest Number of teachers of United Arab Emirates?
Provide a succinct answer. 3225. 